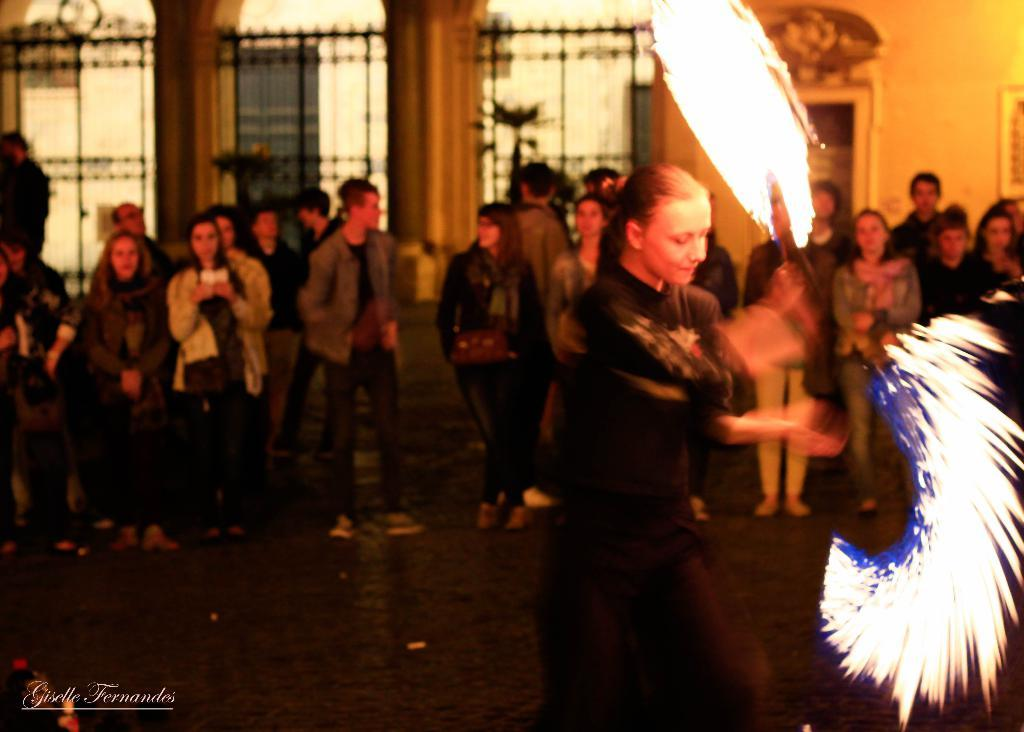Who or what can be seen in the image? There are people in the image. What architectural features are present in the image? There are pillars and a grille in the image. What type of illumination is visible in the image? There are lights in the image. Can you describe any additional elements in the image? There is a watermark in the bottom left corner of the image. What type of jelly can be seen cooking on the stove in the image? There is no stove or jelly present in the image. What type of print is visible on the people in the image? There is no print visible on the people in the image. 